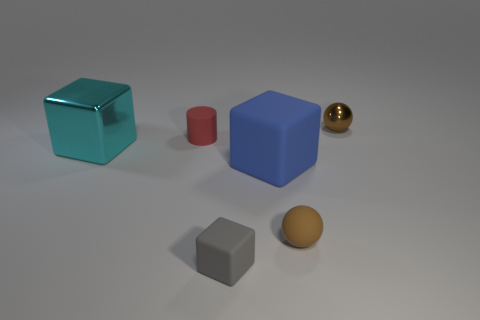There is a small object behind the red rubber cylinder; is its color the same as the tiny sphere that is in front of the red matte thing?
Your answer should be compact. Yes. Are there any cubes that have the same size as the red object?
Offer a terse response. Yes. What number of other gray metallic blocks are the same size as the gray cube?
Provide a succinct answer. 0. There is a rubber cube that is right of the small gray rubber cube; is its size the same as the brown sphere in front of the cyan shiny thing?
Provide a short and direct response. No. How many objects are small brown objects or metal objects that are left of the large blue matte thing?
Ensure brevity in your answer.  3. The rubber cylinder is what color?
Keep it short and to the point. Red. What material is the brown object behind the block to the left of the tiny red matte object behind the cyan metallic cube?
Your answer should be very brief. Metal. There is a brown thing that is made of the same material as the gray cube; what is its size?
Ensure brevity in your answer.  Small. Is there a tiny rubber ball that has the same color as the tiny shiny sphere?
Offer a terse response. Yes. Does the blue cube have the same size as the shiny cube behind the big blue rubber thing?
Make the answer very short. Yes. 